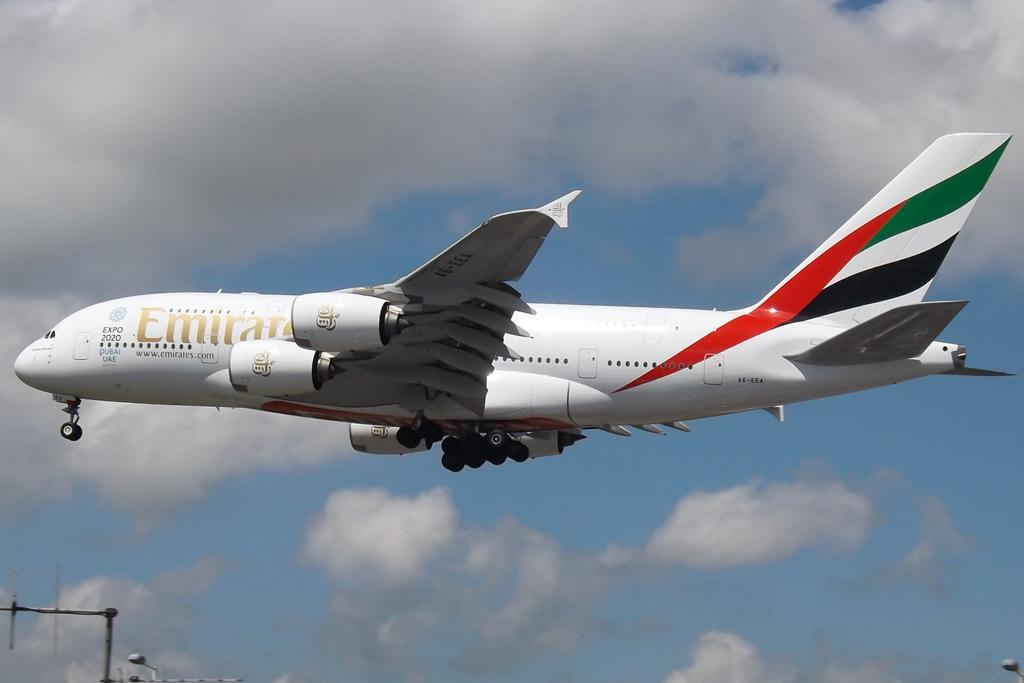<image>
Write a terse but informative summary of the picture. a large Emirite plane is flying through a cloudy sky 